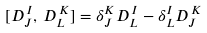Convert formula to latex. <formula><loc_0><loc_0><loc_500><loc_500>[ D _ { J } ^ { \, I } , \, D _ { L } ^ { \, K } ] = \delta _ { J } ^ { K } D _ { L } ^ { \, I } - \delta _ { L } ^ { I } D _ { J } ^ { \, K }</formula> 